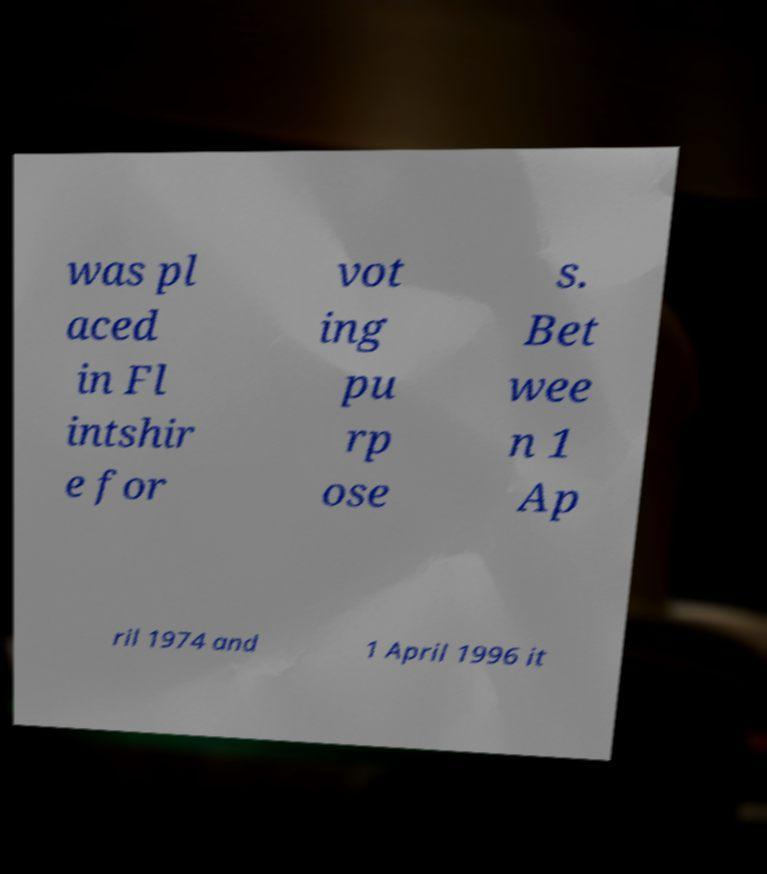Can you accurately transcribe the text from the provided image for me? was pl aced in Fl intshir e for vot ing pu rp ose s. Bet wee n 1 Ap ril 1974 and 1 April 1996 it 